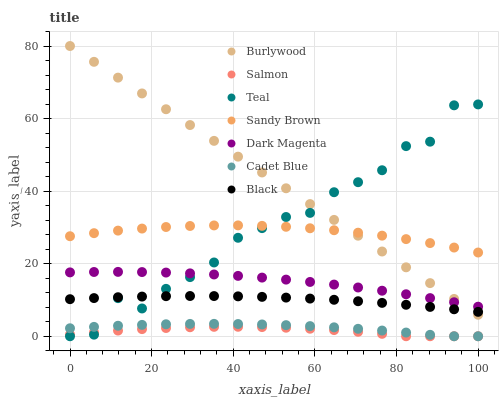Does Salmon have the minimum area under the curve?
Answer yes or no. Yes. Does Burlywood have the maximum area under the curve?
Answer yes or no. Yes. Does Dark Magenta have the minimum area under the curve?
Answer yes or no. No. Does Dark Magenta have the maximum area under the curve?
Answer yes or no. No. Is Burlywood the smoothest?
Answer yes or no. Yes. Is Teal the roughest?
Answer yes or no. Yes. Is Dark Magenta the smoothest?
Answer yes or no. No. Is Dark Magenta the roughest?
Answer yes or no. No. Does Cadet Blue have the lowest value?
Answer yes or no. Yes. Does Dark Magenta have the lowest value?
Answer yes or no. No. Does Burlywood have the highest value?
Answer yes or no. Yes. Does Dark Magenta have the highest value?
Answer yes or no. No. Is Cadet Blue less than Sandy Brown?
Answer yes or no. Yes. Is Sandy Brown greater than Cadet Blue?
Answer yes or no. Yes. Does Burlywood intersect Dark Magenta?
Answer yes or no. Yes. Is Burlywood less than Dark Magenta?
Answer yes or no. No. Is Burlywood greater than Dark Magenta?
Answer yes or no. No. Does Cadet Blue intersect Sandy Brown?
Answer yes or no. No. 